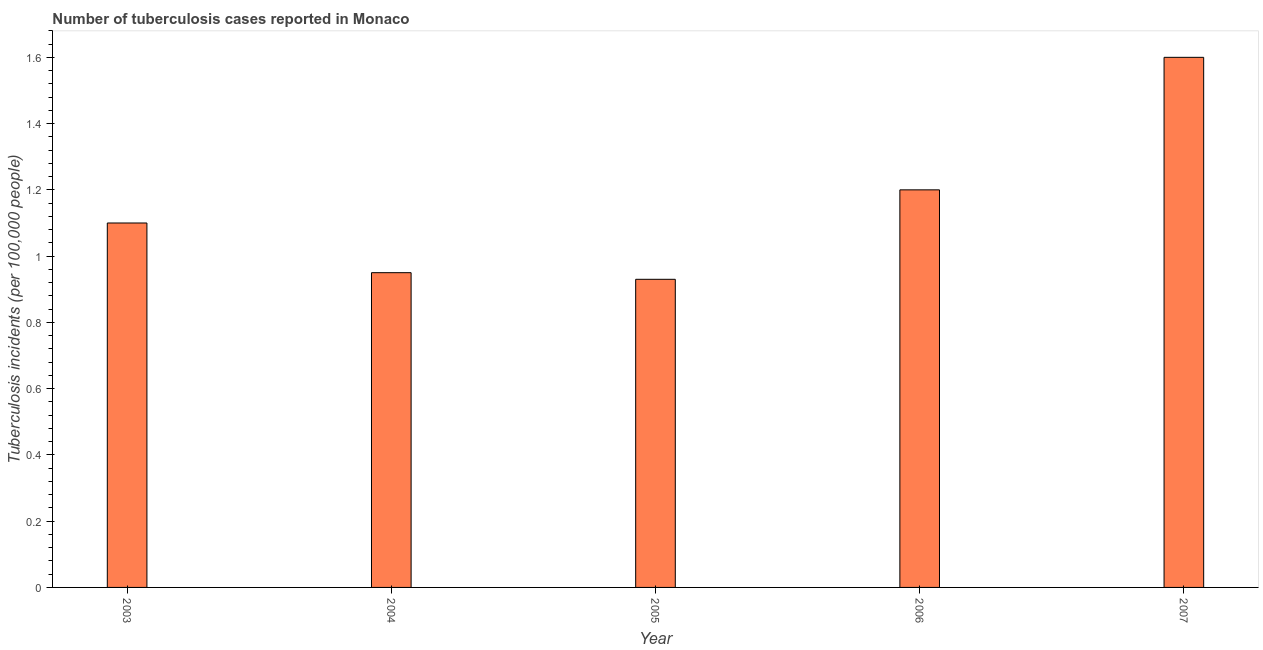Does the graph contain any zero values?
Keep it short and to the point. No. What is the title of the graph?
Your answer should be compact. Number of tuberculosis cases reported in Monaco. What is the label or title of the Y-axis?
Give a very brief answer. Tuberculosis incidents (per 100,0 people). Across all years, what is the maximum number of tuberculosis incidents?
Your answer should be very brief. 1.6. Across all years, what is the minimum number of tuberculosis incidents?
Make the answer very short. 0.93. In which year was the number of tuberculosis incidents maximum?
Make the answer very short. 2007. In which year was the number of tuberculosis incidents minimum?
Your answer should be compact. 2005. What is the sum of the number of tuberculosis incidents?
Provide a succinct answer. 5.78. What is the average number of tuberculosis incidents per year?
Provide a succinct answer. 1.16. What is the median number of tuberculosis incidents?
Provide a succinct answer. 1.1. Do a majority of the years between 2006 and 2004 (inclusive) have number of tuberculosis incidents greater than 0.52 ?
Offer a terse response. Yes. What is the ratio of the number of tuberculosis incidents in 2004 to that in 2007?
Offer a terse response. 0.59. Is the number of tuberculosis incidents in 2005 less than that in 2007?
Provide a short and direct response. Yes. What is the difference between the highest and the second highest number of tuberculosis incidents?
Make the answer very short. 0.4. Is the sum of the number of tuberculosis incidents in 2004 and 2006 greater than the maximum number of tuberculosis incidents across all years?
Offer a terse response. Yes. What is the difference between the highest and the lowest number of tuberculosis incidents?
Make the answer very short. 0.67. How many bars are there?
Give a very brief answer. 5. Are all the bars in the graph horizontal?
Offer a terse response. No. What is the difference between two consecutive major ticks on the Y-axis?
Your answer should be very brief. 0.2. What is the Tuberculosis incidents (per 100,000 people) of 2007?
Ensure brevity in your answer.  1.6. What is the difference between the Tuberculosis incidents (per 100,000 people) in 2003 and 2004?
Offer a terse response. 0.15. What is the difference between the Tuberculosis incidents (per 100,000 people) in 2003 and 2005?
Make the answer very short. 0.17. What is the difference between the Tuberculosis incidents (per 100,000 people) in 2003 and 2006?
Offer a terse response. -0.1. What is the difference between the Tuberculosis incidents (per 100,000 people) in 2003 and 2007?
Your answer should be very brief. -0.5. What is the difference between the Tuberculosis incidents (per 100,000 people) in 2004 and 2006?
Ensure brevity in your answer.  -0.25. What is the difference between the Tuberculosis incidents (per 100,000 people) in 2004 and 2007?
Provide a succinct answer. -0.65. What is the difference between the Tuberculosis incidents (per 100,000 people) in 2005 and 2006?
Provide a short and direct response. -0.27. What is the difference between the Tuberculosis incidents (per 100,000 people) in 2005 and 2007?
Provide a succinct answer. -0.67. What is the ratio of the Tuberculosis incidents (per 100,000 people) in 2003 to that in 2004?
Offer a very short reply. 1.16. What is the ratio of the Tuberculosis incidents (per 100,000 people) in 2003 to that in 2005?
Make the answer very short. 1.18. What is the ratio of the Tuberculosis incidents (per 100,000 people) in 2003 to that in 2006?
Offer a very short reply. 0.92. What is the ratio of the Tuberculosis incidents (per 100,000 people) in 2003 to that in 2007?
Provide a short and direct response. 0.69. What is the ratio of the Tuberculosis incidents (per 100,000 people) in 2004 to that in 2005?
Your answer should be compact. 1.02. What is the ratio of the Tuberculosis incidents (per 100,000 people) in 2004 to that in 2006?
Ensure brevity in your answer.  0.79. What is the ratio of the Tuberculosis incidents (per 100,000 people) in 2004 to that in 2007?
Your answer should be very brief. 0.59. What is the ratio of the Tuberculosis incidents (per 100,000 people) in 2005 to that in 2006?
Keep it short and to the point. 0.78. What is the ratio of the Tuberculosis incidents (per 100,000 people) in 2005 to that in 2007?
Ensure brevity in your answer.  0.58. What is the ratio of the Tuberculosis incidents (per 100,000 people) in 2006 to that in 2007?
Ensure brevity in your answer.  0.75. 